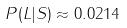<formula> <loc_0><loc_0><loc_500><loc_500>P ( L | S ) \approx 0 . 0 2 1 4</formula> 